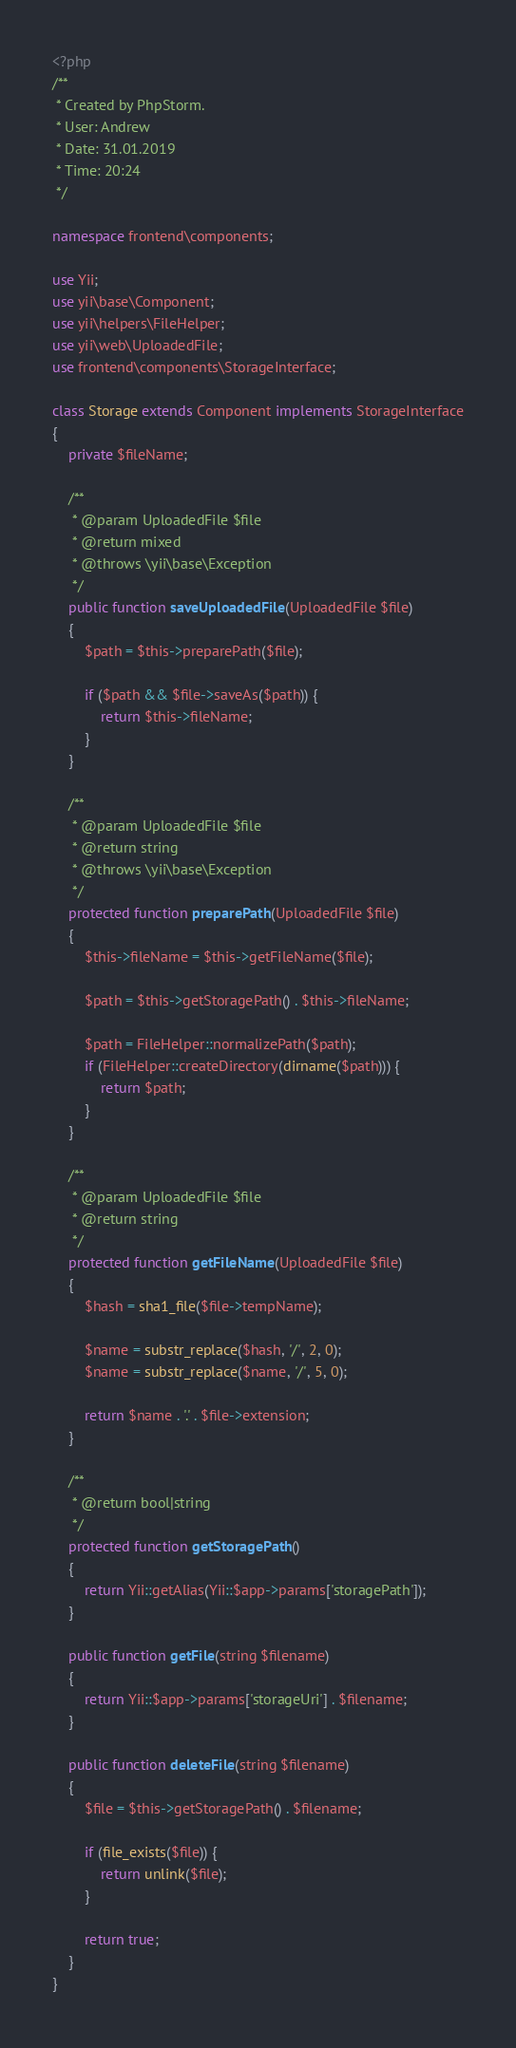<code> <loc_0><loc_0><loc_500><loc_500><_PHP_><?php
/**
 * Created by PhpStorm.
 * User: Andrew
 * Date: 31.01.2019
 * Time: 20:24
 */

namespace frontend\components;

use Yii;
use yii\base\Component;
use yii\helpers\FileHelper;
use yii\web\UploadedFile;
use frontend\components\StorageInterface;

class Storage extends Component implements StorageInterface
{
    private $fileName;

    /**
     * @param UploadedFile $file
     * @return mixed
     * @throws \yii\base\Exception
     */
    public function saveUploadedFile(UploadedFile $file)
    {
        $path = $this->preparePath($file);

        if ($path && $file->saveAs($path)) {
            return $this->fileName;
        }
    }

    /**
     * @param UploadedFile $file
     * @return string
     * @throws \yii\base\Exception
     */
    protected function preparePath(UploadedFile $file)
    {
        $this->fileName = $this->getFileName($file);

        $path = $this->getStoragePath() . $this->fileName;

        $path = FileHelper::normalizePath($path);
        if (FileHelper::createDirectory(dirname($path))) {
            return $path;
        }
    }

    /**
     * @param UploadedFile $file
     * @return string
     */
    protected function getFileName(UploadedFile $file)
    {
        $hash = sha1_file($file->tempName);

        $name = substr_replace($hash, '/', 2, 0);
        $name = substr_replace($name, '/', 5, 0);

        return $name . '.' . $file->extension;
    }

    /**
     * @return bool|string
     */
    protected function getStoragePath()
    {
        return Yii::getAlias(Yii::$app->params['storagePath']);
    }

    public function getFile(string $filename)
    {
        return Yii::$app->params['storageUri'] . $filename;
    }

    public function deleteFile(string $filename)
    {
        $file = $this->getStoragePath() . $filename;

        if (file_exists($file)) {
            return unlink($file);
        }

        return true;
    }
}</code> 